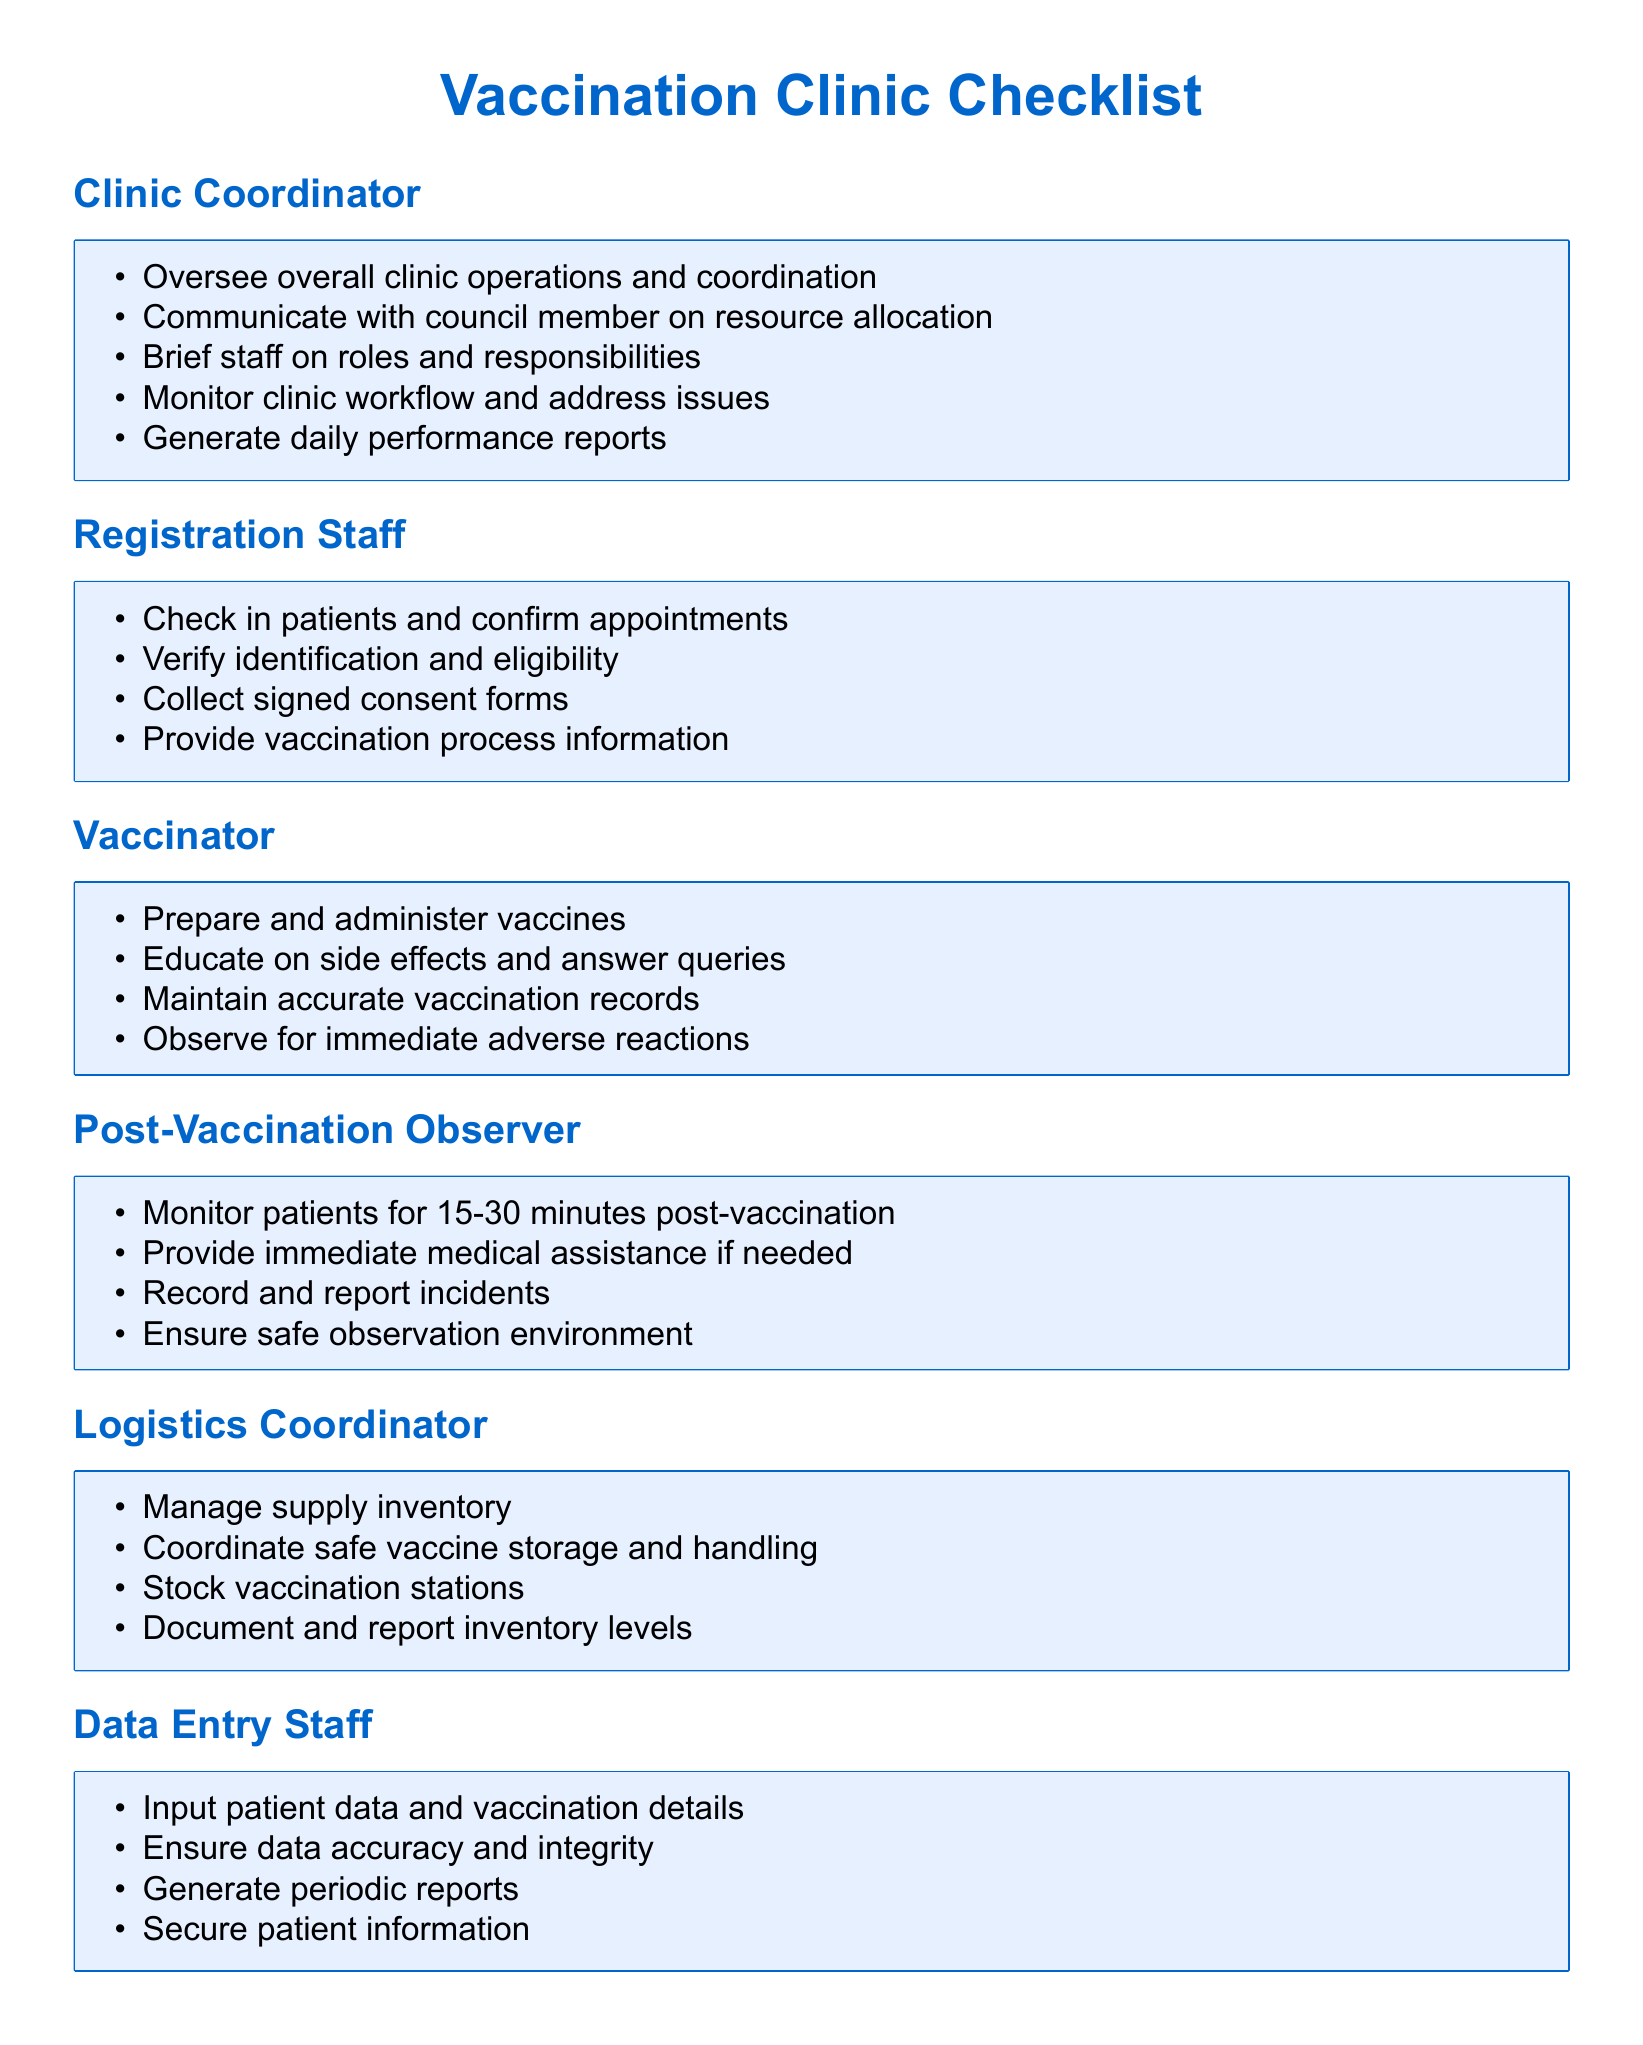What is the role of the Clinic Coordinator? The Clinic Coordinator is responsible for overseeing overall clinic operations and coordination.
Answer: Oversee overall clinic operations and coordination Who is responsible for checking in patients? The Registration Staff is tasked with checking in patients and confirming appointments.
Answer: Registration Staff How long should patients be monitored post-vaccination? Patients should be monitored for 15-30 minutes post-vaccination by the Post-Vaccination Observer.
Answer: 15-30 minutes What does the Logistics Coordinator manage? The Logistics Coordinator manages supply inventory, which includes coordinating safe vaccine storage and handling.
Answer: Supply inventory What must Data Entry Staff ensure regarding patient information? The Data Entry Staff must ensure the accuracy and integrity of patient information they input.
Answer: Data accuracy and integrity 